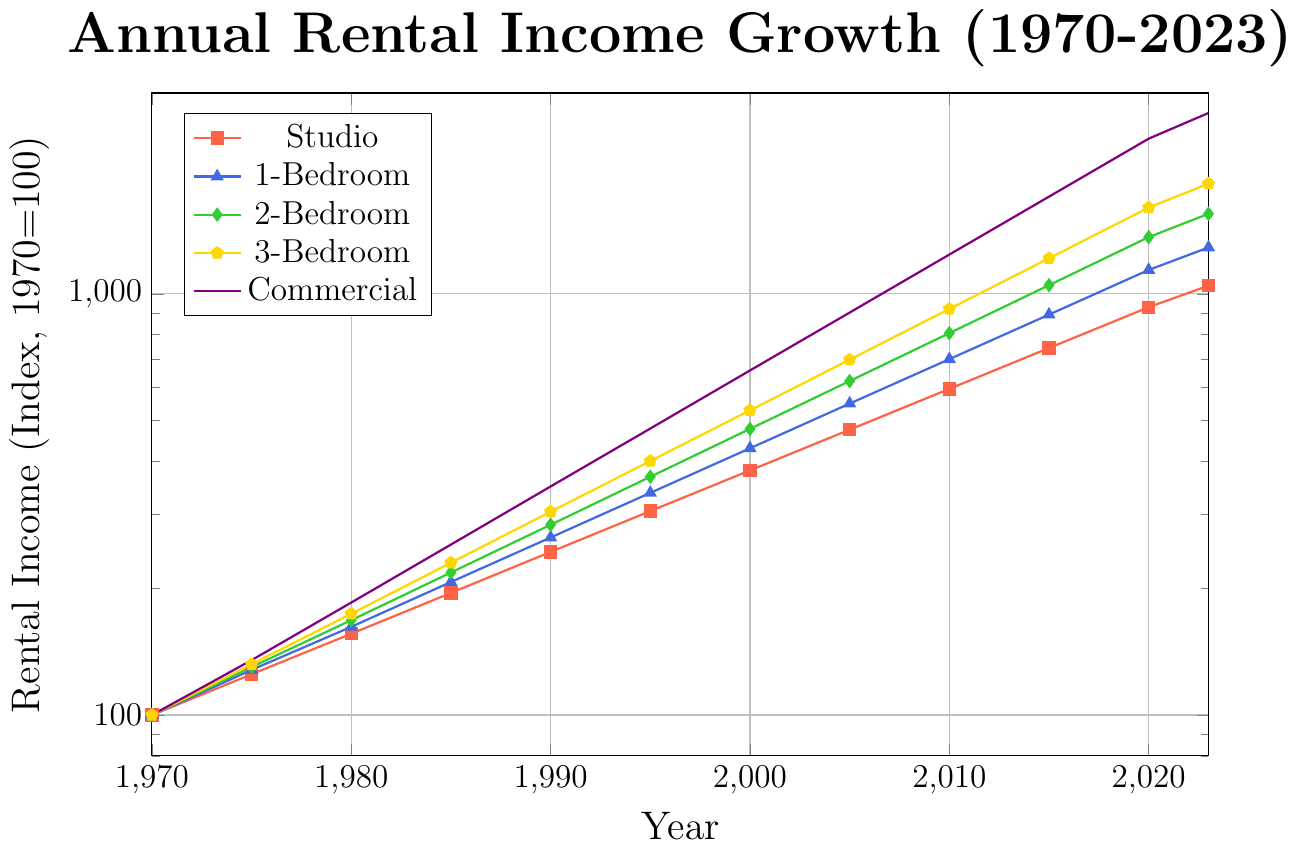What is the overall trend for rental incomes from 1970 to 2023? Observing the entire plot from 1970 to 2023, all property types show an increasing trend in rental incomes over time, indicating steady growth.
Answer: Increasing Which property type has the highest rental income in 2023? The plot's highest point in 2023 is for the "Commercial" property, marked with a star symbol, indicating that commercial properties have the highest rental income in 2023.
Answer: Commercial How does the rental income growth of 1-Bedroom properties compare to 2-Bedroom properties between 1980 and 1990? From the graph, the rental income for 1-Bedroom properties grows from 162 in 1980 to 264 in 1990, while for 2-Bedroom properties, it grows from 168 in 1980 to 283 in 1990. Both show a significant increase, but 2-Bedroom properties have a slightly higher growth over this period.
Answer: 2-Bedroom has slightly higher growth What is the difference in rental income between Studio and 3-Bedroom properties in 2020? In 2020, the rental income for Studio properties is 930, and for 3-Bedroom properties, it is 1603. The difference is calculated as 1603 - 930 = 673.
Answer: 673 Between 2005 and 2010, which property type had the highest percentage growth in rental income? Calculate the percentage growth for each property type over this period. For instance, for Studio, the growth is (595-476)/476 * 100 = 25%. Repeat for other property types. The Commercial property shows the highest percentage increase, from 903 to 1240 ((1240-903)/903 * 100 ≈ 37.3%).
Answer: Commercial Which property type has the most consistent growth trend from 1970 to 2023? The plot lines for all property types show overall consistent growth, but the Studio properties' line has fewer fluctuations compared to others, indicating more consistent growth.
Answer: Studio What is the ratio of rental income between Commercial and 1-Bedroom properties in 2015? The rental income for Commercial properties in 2015 is 1702, and for 1-Bedroom properties, it is 893. The ratio is 1702 / 893 ≈ 1.9.
Answer: 1.9 How much more rental income does a 3-Bedroom property generate compared to a 1-Bedroom property in 1995? In 1995, the rental income for a 3-Bedroom property is 401 and for a 1-Bedroom property, it is 337. The difference is 401 - 337 = 64.
Answer: 64 What is the average rental income of Studio properties for the years 2000, 2005, and 2010? First, sum the rental incomes for Studio properties in these years: 381 (2000) + 476 (2005) + 595 (2010) = 1452. Then, divide by the number of years: 1452 / 3 ≈ 484.
Answer: 484 Which property type shows the highest increase in rental income from 2010 to 2023? By calculating the increase for each property type, it becomes clear that Commercial properties show the highest increase, from 1240 in 2010 to 2689 in 2023, an increase of 1449.
Answer: Commercial 